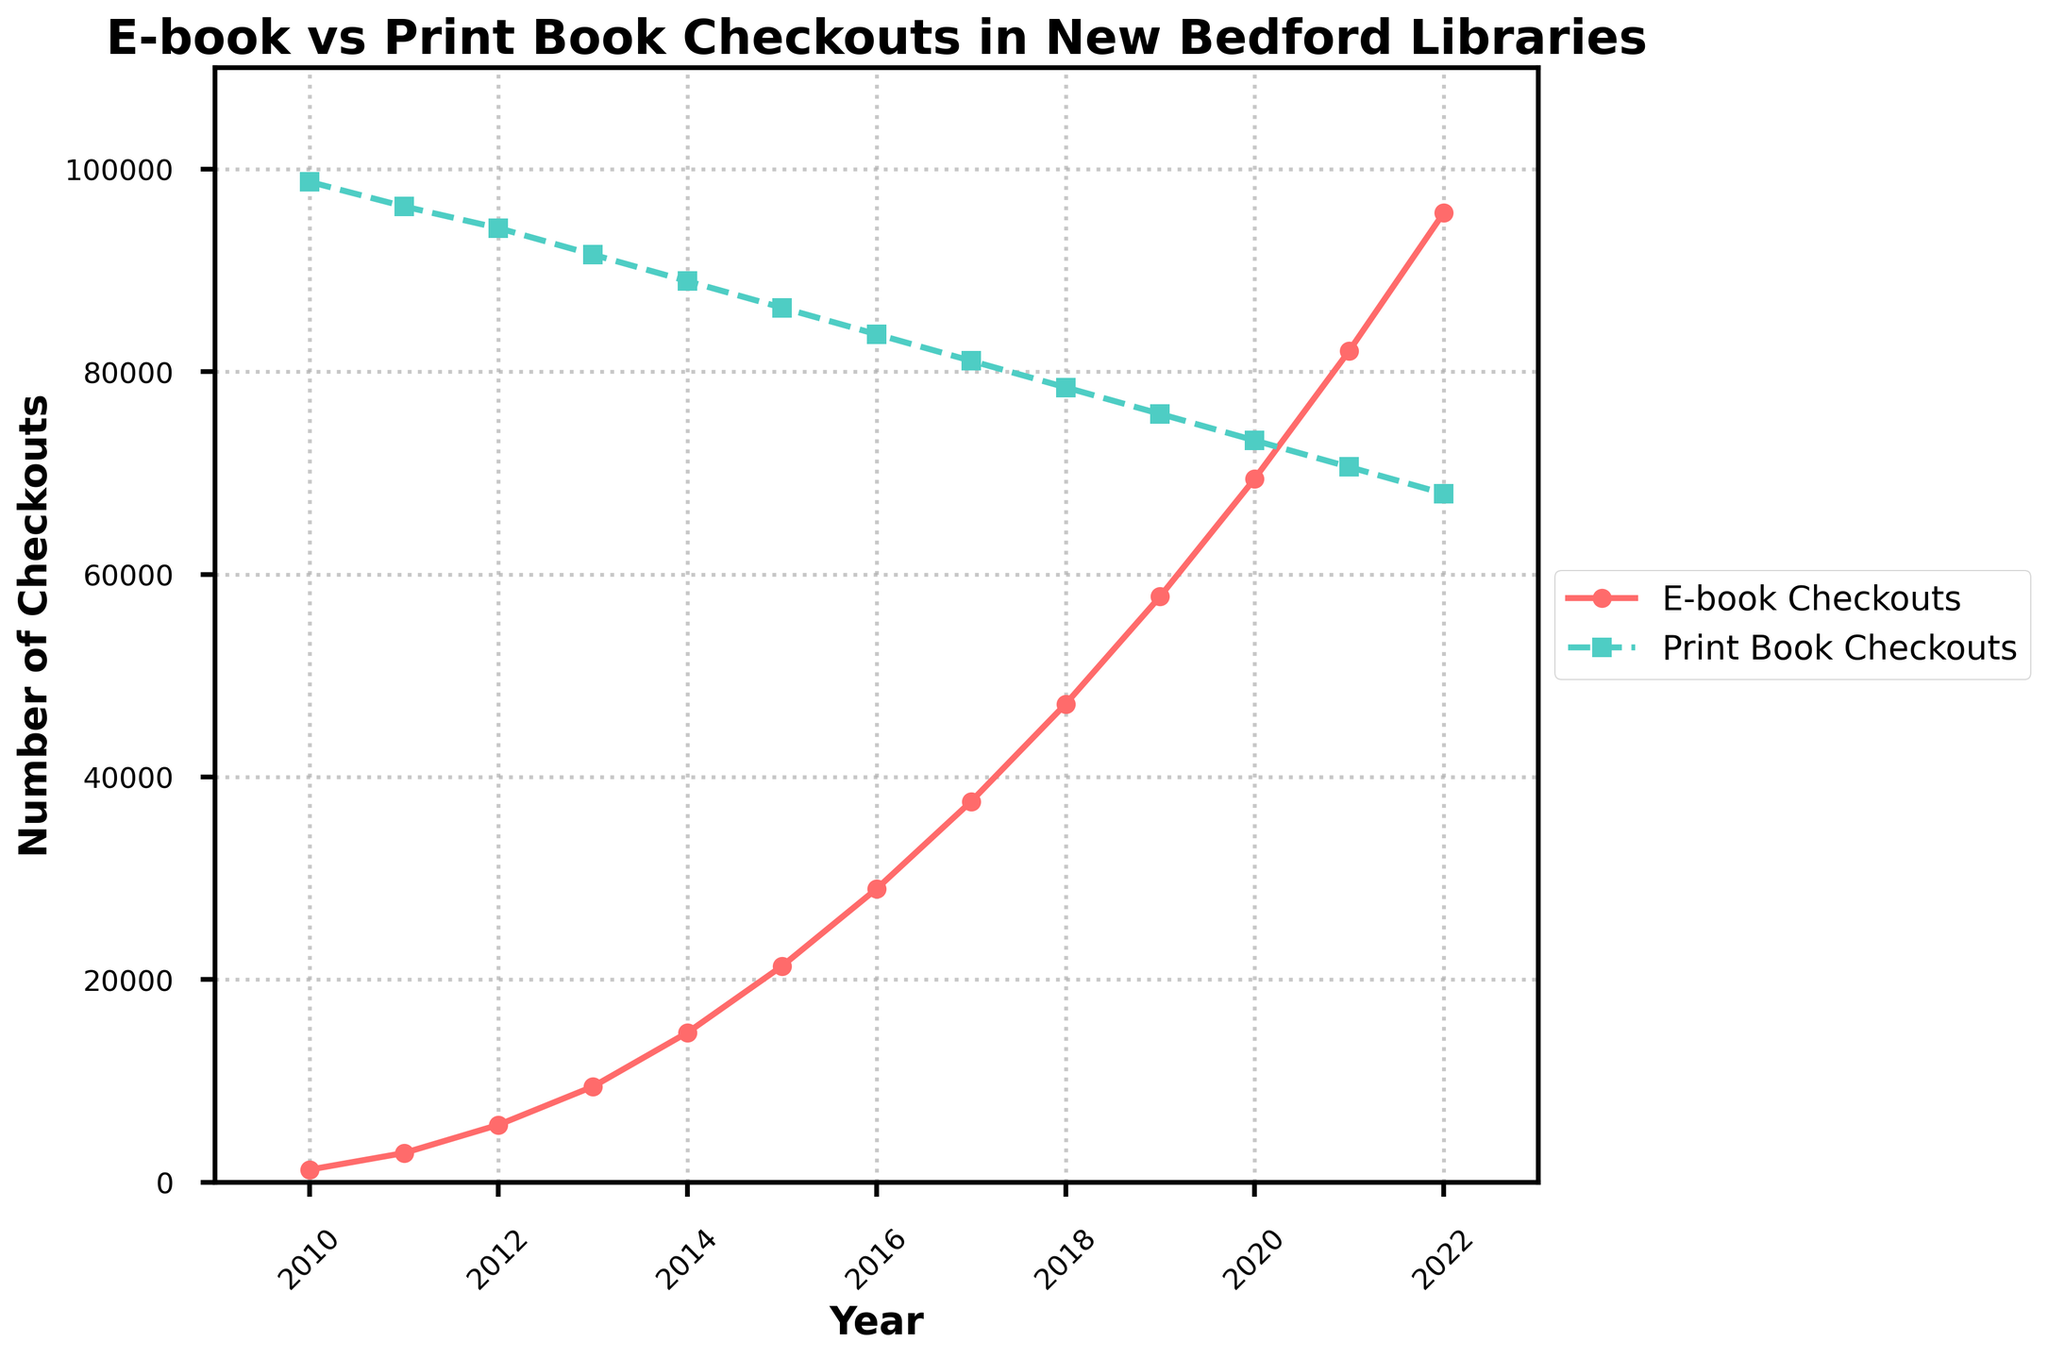What year saw the highest number of print book checkouts? To find the highest number of print book checkouts, look for the peak value in the "Print Book Checkouts" series. The peak value of 98750 occurs in 2010.
Answer: 2010 In which year did e-book checkouts surpass print book checkouts? Identify when the e-book checkouts line first crosses above the print book checkouts line on the graph. By observing the plot, this occurs in 2021.
Answer: 2021 What is the difference between the number of e-book checkouts and print book checkouts in 2022? Extract the values for 2022: E-book checkouts are 95680 and print book checkouts are 67980. Calculate the difference as 95680 - 67980 = 27700.
Answer: 27700 How does the trend of e-book checkouts from 2010 to 2022 compare to the trend of print book checkouts in the same period? Observe the general direction of both trends. E-book checkouts show a consistent increase over time, while print book checkouts steadily decline.
Answer: E-books increase; print books decline Which type of checkout shows a steadier trend over the years? Assess the plot for fluctuations in both lines. The print book checkouts show a steadier (more gradually decreasing) trend, while e-book checkouts have a sharper increase with variability in the slope.
Answer: Print book checkouts What is the combined total of e-book and print book checkouts in 2020? Sum the values for both types of checkouts in 2020. E-book checkouts are 69440, and print book checkouts are 73220. The total is 69440 + 73220 = 142660.
Answer: 142660 Which year shows the greatest increase in e-book checkouts from the previous year? Calculate the year-on-year changes for e-book checkouts: 
2011-2010: 2890 - 1245 = 1645 
2012-2011: 5670 - 2890 = 2780 
2013-2012: 9450 - 5670 = 3780 
2014-2013: 14780 - 9450 = 5330 
2015-2014: 21340 - 14780 = 6560 
2016-2015: 28960 - 21340 = 7620 
2017-2016: 37580 - 28960 = 8620 
2018-2017: 47200 - 37580 = 9620 
2019-2018: 57820 - 47200 = 10620 
2020-2019: 69440 - 57820 = 11620 
2021-2020: 82060 - 69440 = 12620 
2022-2021: 95680 - 82060 = 13620 
2022 shows the greatest increase with 13620.
Answer: 2022 How many times greater were print book checkouts than e-book checkouts in 2010? Divide the print book checkouts by the e-book checkouts for 2010. Print book checkouts are 98750, and e-book checkouts are 1245. 98750 / 1245 ≈ 79.32.
Answer: ~79 times When did e-book checkouts first surpass 10,000? Examine the e-book checkouts values over the years. The value first surpasses 10,000 in 2014.
Answer: 2014 